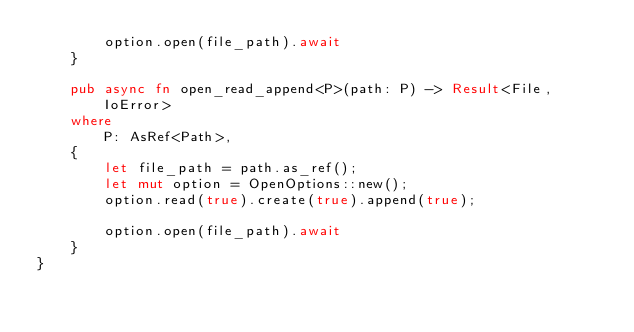<code> <loc_0><loc_0><loc_500><loc_500><_Rust_>        option.open(file_path).await
    }

    pub async fn open_read_append<P>(path: P) -> Result<File, IoError>
    where
        P: AsRef<Path>,
    {
        let file_path = path.as_ref();
        let mut option = OpenOptions::new();
        option.read(true).create(true).append(true);

        option.open(file_path).await
    }
}





</code> 